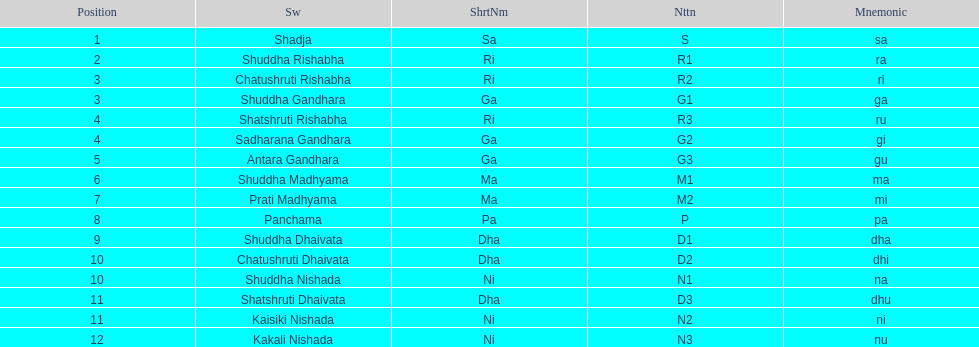On average how many of the swara have a short name that begin with d or g? 6. Could you parse the entire table as a dict? {'header': ['Position', 'Sw', 'ShrtNm', 'Nttn', 'Mnemonic'], 'rows': [['1', 'Shadja', 'Sa', 'S', 'sa'], ['2', 'Shuddha Rishabha', 'Ri', 'R1', 'ra'], ['3', 'Chatushruti Rishabha', 'Ri', 'R2', 'ri'], ['3', 'Shuddha Gandhara', 'Ga', 'G1', 'ga'], ['4', 'Shatshruti Rishabha', 'Ri', 'R3', 'ru'], ['4', 'Sadharana Gandhara', 'Ga', 'G2', 'gi'], ['5', 'Antara Gandhara', 'Ga', 'G3', 'gu'], ['6', 'Shuddha Madhyama', 'Ma', 'M1', 'ma'], ['7', 'Prati Madhyama', 'Ma', 'M2', 'mi'], ['8', 'Panchama', 'Pa', 'P', 'pa'], ['9', 'Shuddha Dhaivata', 'Dha', 'D1', 'dha'], ['10', 'Chatushruti Dhaivata', 'Dha', 'D2', 'dhi'], ['10', 'Shuddha Nishada', 'Ni', 'N1', 'na'], ['11', 'Shatshruti Dhaivata', 'Dha', 'D3', 'dhu'], ['11', 'Kaisiki Nishada', 'Ni', 'N2', 'ni'], ['12', 'Kakali Nishada', 'Ni', 'N3', 'nu']]} 